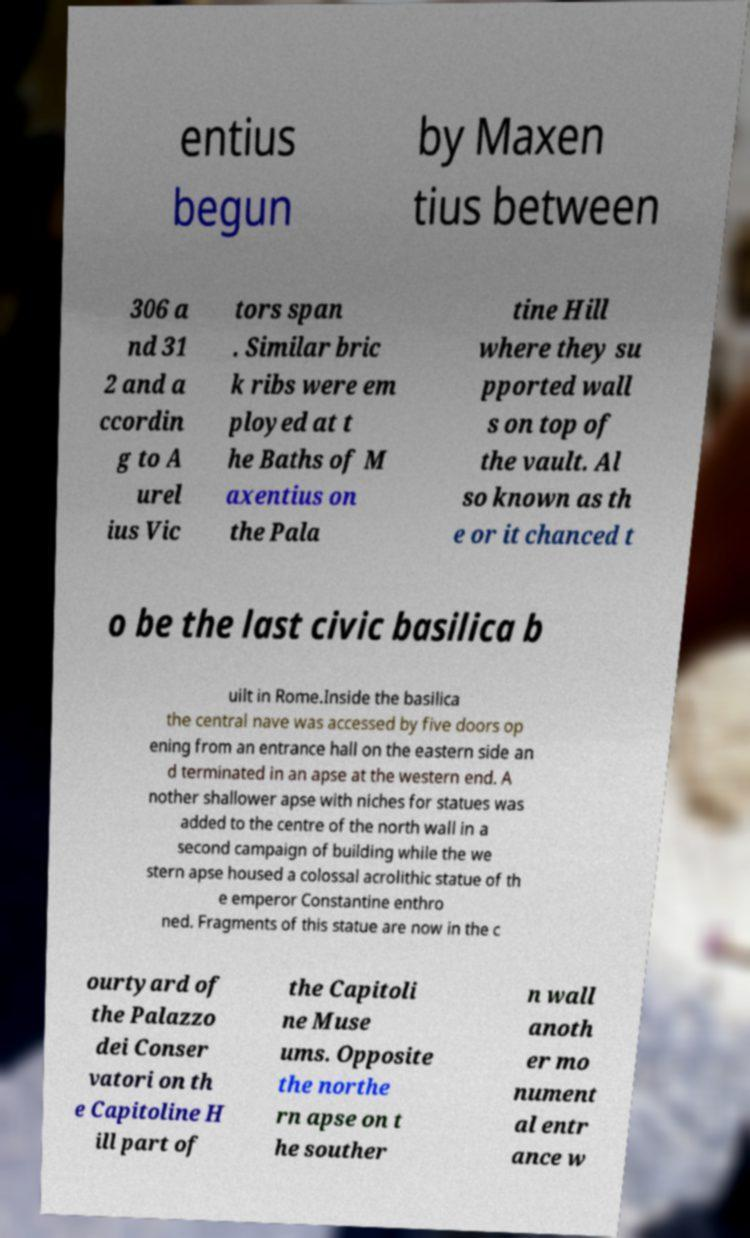Could you assist in decoding the text presented in this image and type it out clearly? entius begun by Maxen tius between 306 a nd 31 2 and a ccordin g to A urel ius Vic tors span . Similar bric k ribs were em ployed at t he Baths of M axentius on the Pala tine Hill where they su pported wall s on top of the vault. Al so known as th e or it chanced t o be the last civic basilica b uilt in Rome.Inside the basilica the central nave was accessed by five doors op ening from an entrance hall on the eastern side an d terminated in an apse at the western end. A nother shallower apse with niches for statues was added to the centre of the north wall in a second campaign of building while the we stern apse housed a colossal acrolithic statue of th e emperor Constantine enthro ned. Fragments of this statue are now in the c ourtyard of the Palazzo dei Conser vatori on th e Capitoline H ill part of the Capitoli ne Muse ums. Opposite the northe rn apse on t he souther n wall anoth er mo nument al entr ance w 